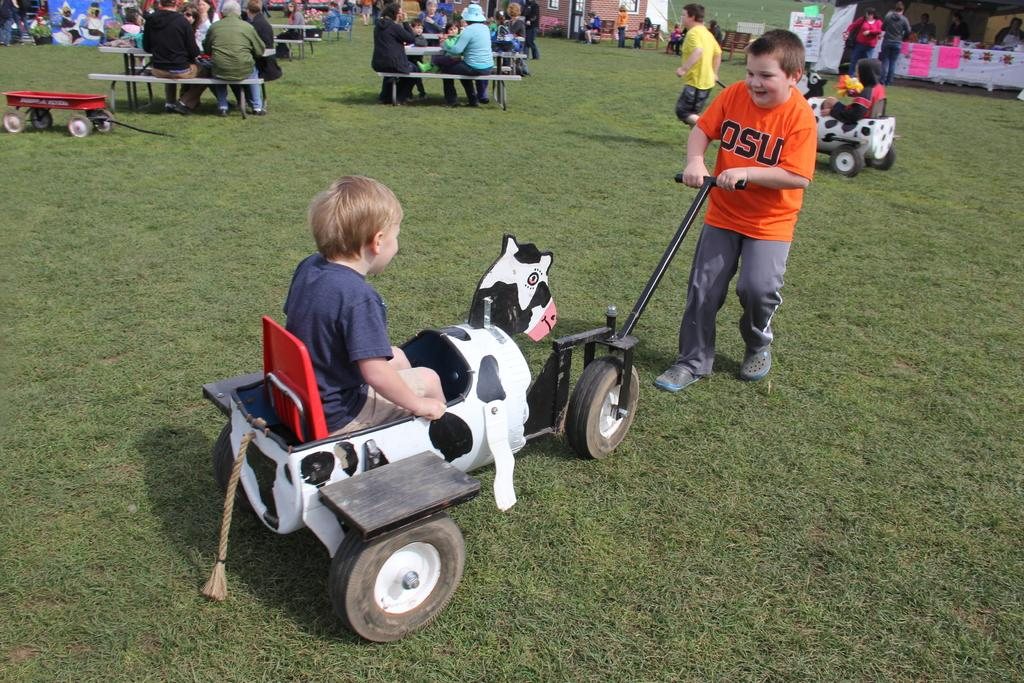How many people are in the image? There is a group of people in the image, but the exact number is not specified. What are the people doing in the image? The people are on the ground in the image. What type of objects can be seen in the image besides the people? There are toy vehicles and benches in the image. What are the unspecified objects in the image? The nature of the unspecified objects is not described in the facts provided. What type of pest can be seen crawling on the toy vehicles in the image? There is no pest visible on the toy vehicles in the image. On which side of the benches are the people sitting in the image? The facts provided do not specify which side of the benches the people are sitting on. 